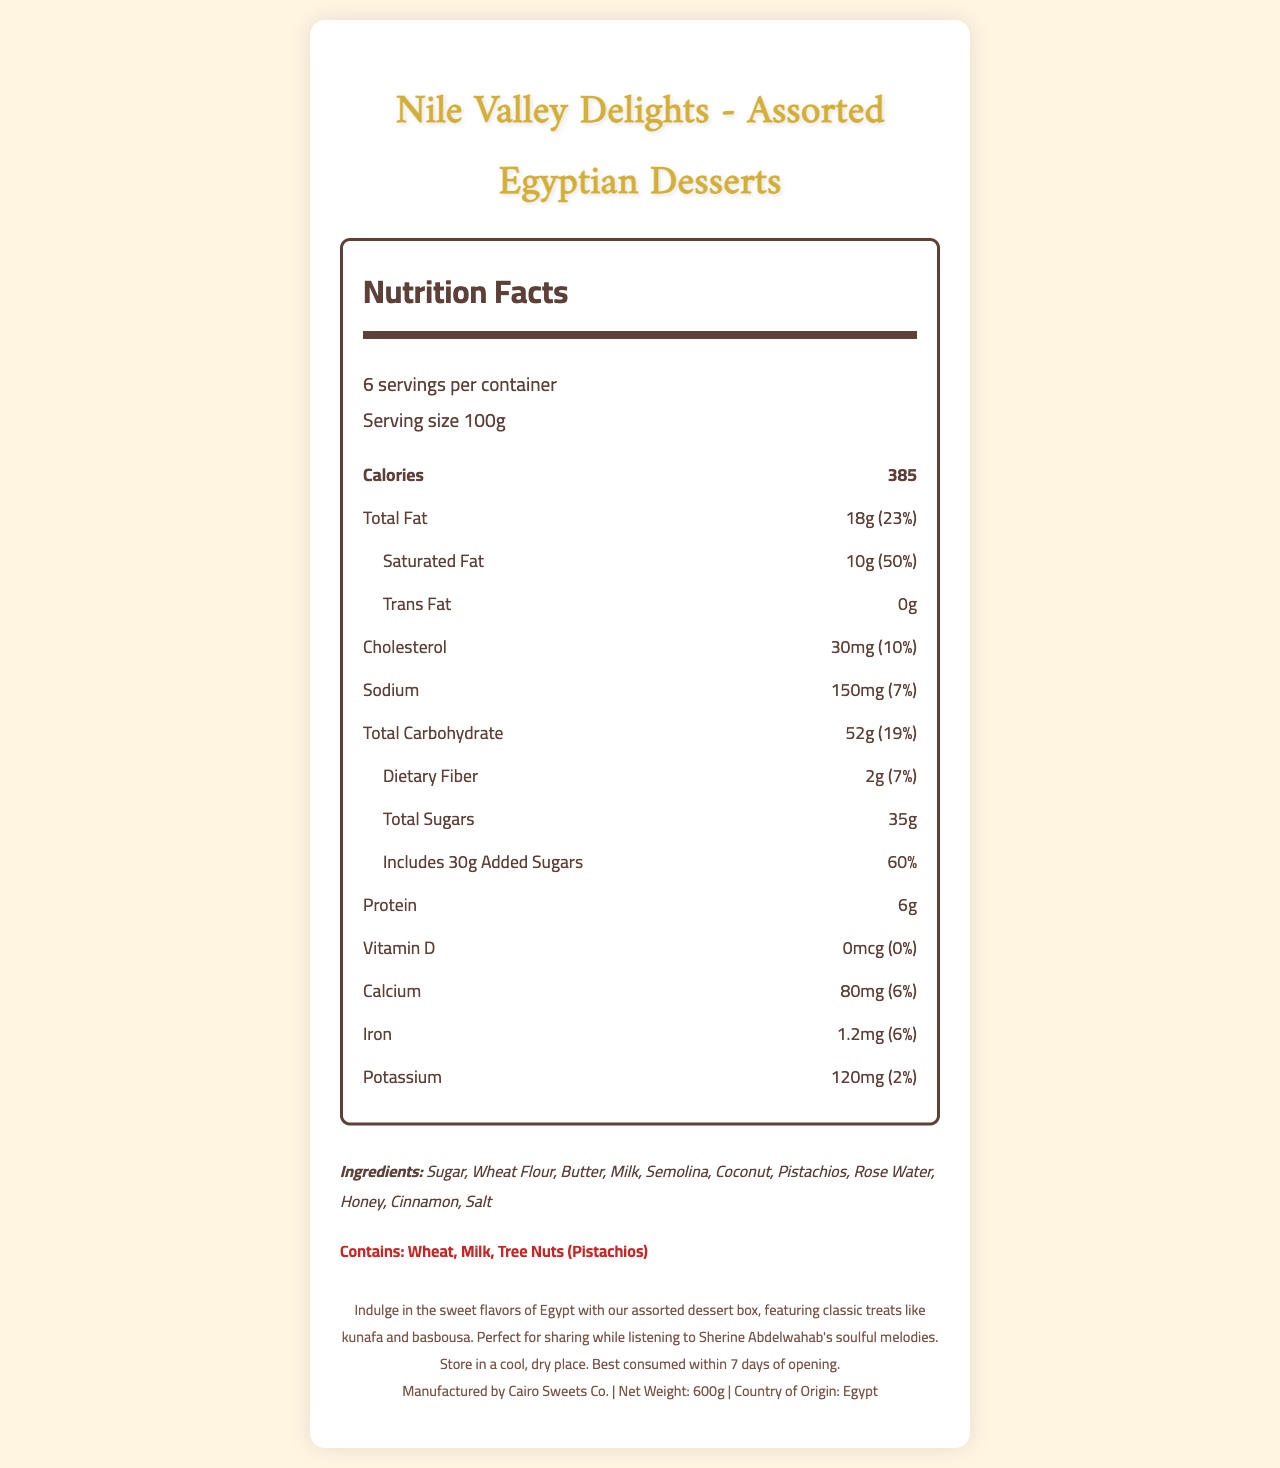what is the serving size for Nile Valley Delights - Assorted Egyptian Desserts? The serving size is listed as 100g under the serving information section.
Answer: 100g how many servings are there per container? The document states that there are 6 servings per container.
Answer: 6 how many calories are there per serving? The number of calories per serving is listed as 385 in the nutrition facts section.
Answer: 385 how much total carbohydrate is in each serving? The total carbohydrate amount per serving is 52g, as shown in the nutrition facts section.
Answer: 52g how much total sugars are there in one serving? The amount of total sugars is listed as 35g under the total carbohydrate section.
Answer: 35g how much added sugars does each serving contain, and what percentage of the daily value does that represent? Each serving contains 30g of added sugars, which is 60% of the daily value.
Answer: 30g, 60% what are the main ingredients in these desserts? The ingredients list includes these main items, as mentioned in the ingredients section.
Answer: Sugar, Wheat Flour, Butter, Milk, Semolina, Coconut, Pistachios, Rose Water, Honey, Cinnamon, Salt which allergens are present in Nile Valley Delights? The allergens are listed as Wheat, Milk, and Tree Nuts (Pistachios) in the allergens section.
Answer: Wheat, Milk, Tree Nuts (Pistachios) how much saturated fat is in one serving, and how does it compare to the daily value? One serving contains 10g of saturated fat, which is 50% of the daily value.
Answer: 10g, 50% how much sodium is there per serving? A. 100mg B. 150mg C. 200mg The sodium amount per serving is 150mg, as indicated in the nutrition facts.
Answer: B. 150mg how many grams of dietary fiber are in each serving? A. 1g B. 2g C. 3g There are 2g of dietary fiber per serving, as specified in the nutrition facts.
Answer: B. 2g is there any trans fat in these desserts? The document lists trans fat as 0g, indicating there is no trans fat.
Answer: No is Vitamin D present in any amount in this product? The nutrition facts show 0mcg of Vitamin D, meaning it is not present in the product.
Answer: No how would you describe the entire document in one sentence? This summary captures the essence of the document by mentioning the key nutritional details, the ingredients and allergens, and a cultural touchpoint relevant to the target audience.
Answer: The document provides detailed nutrition facts, ingredients, and allergen information for Nile Valley Delights - Assorted Egyptian Desserts, focusing on carbohydrate and sugar content among other nutritional values, ideal for enjoying with Sherine Abdelwahab's music. how should the product be stored after opening? The storage instructions are specified in the footer of the document.
Answer: Store in a cool, dry place. Best consumed within 7 days of opening. who is the manufacturer of Nile Valley Delights? The manufacturer is listed at the bottom of the document as Cairo Sweets Co.
Answer: Cairo Sweets Co. what is the net weight of the product? The net weight of the product is 600g, as mentioned in the footer of the document.
Answer: 600g how much calcium is in one serving? One serving contains 80mg of calcium, as stated in the nutrition facts section.
Answer: 80mg what is the daily value percentage for iron in these desserts? The daily value percentage for iron is listed as 6% in the nutrition facts.
Answer: 6% what is the origin country of Nile Valley Delights? The country of origin is Egypt, as specified in the footer of the document.
Answer: Egypt which famous artist's music is recommended to enjoy with these desserts? The product description suggests enjoying the desserts while listening to Sherine Abdelwahab.
Answer: Sherine Abdelwahab how many calories are in the entire box? With 6 servings per container and 385 calories per serving, the entire box contains 2310 calories (385 calories x 6 servings).
Answer: 2310 when was the product manufactured? The document does not provide any information on the manufacturing date, so the answer is "Cannot be determined".
Answer: Cannot be determined what are the visually presented instructions for consuming the product? The visual document specifies the storage instructions, but there are no specific consumption instructions beyond storage.
Answer: Store in a cool, dry place. Best consumed within 7 days of opening. 